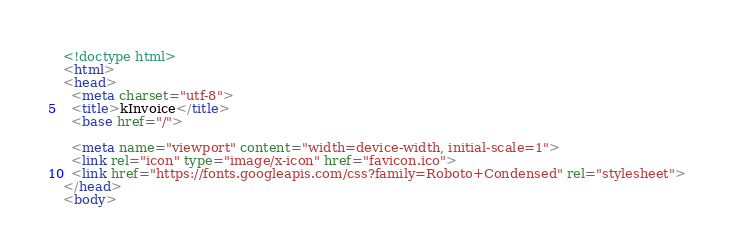Convert code to text. <code><loc_0><loc_0><loc_500><loc_500><_HTML_><!doctype html>
<html>
<head>
  <meta charset="utf-8">
  <title>kInvoice</title>
  <base href="/">

  <meta name="viewport" content="width=device-width, initial-scale=1">
  <link rel="icon" type="image/x-icon" href="favicon.ico">
  <link href="https://fonts.googleapis.com/css?family=Roboto+Condensed" rel="stylesheet">
</head>
<body></code> 